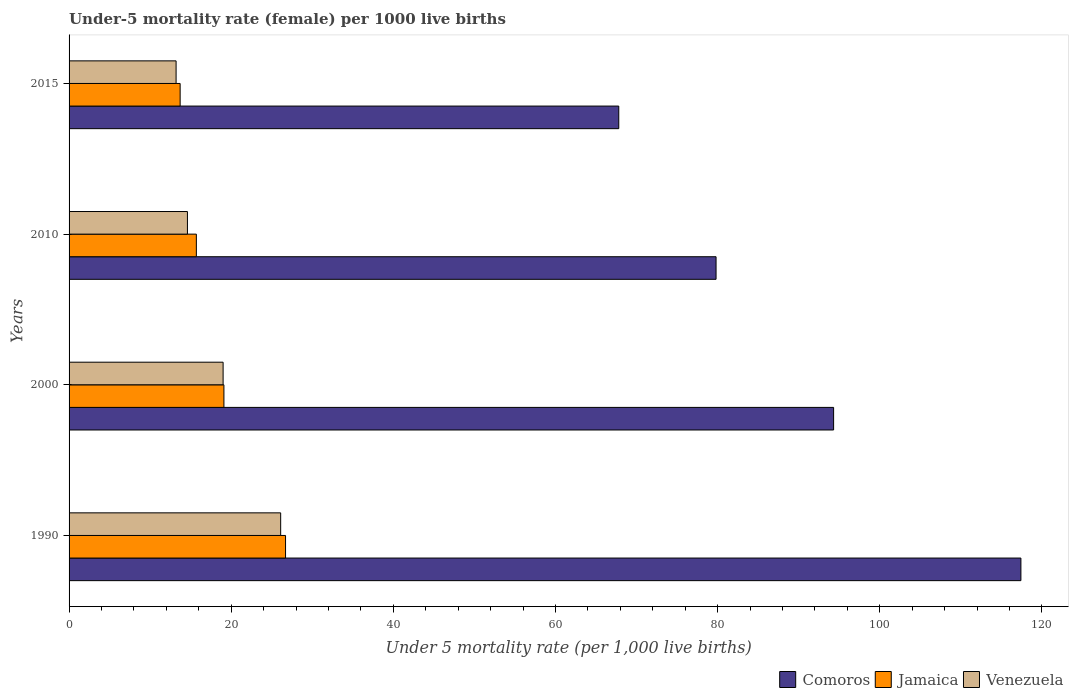How many different coloured bars are there?
Make the answer very short. 3. Are the number of bars on each tick of the Y-axis equal?
Keep it short and to the point. Yes. How many bars are there on the 4th tick from the top?
Provide a short and direct response. 3. What is the label of the 3rd group of bars from the top?
Offer a terse response. 2000. What is the under-five mortality rate in Comoros in 1990?
Keep it short and to the point. 117.4. Across all years, what is the maximum under-five mortality rate in Venezuela?
Your response must be concise. 26.1. Across all years, what is the minimum under-five mortality rate in Jamaica?
Keep it short and to the point. 13.7. In which year was the under-five mortality rate in Comoros minimum?
Your answer should be very brief. 2015. What is the total under-five mortality rate in Venezuela in the graph?
Offer a very short reply. 72.9. What is the difference between the under-five mortality rate in Jamaica in 1990 and that in 2000?
Offer a very short reply. 7.6. In the year 2010, what is the difference between the under-five mortality rate in Jamaica and under-five mortality rate in Venezuela?
Offer a terse response. 1.1. In how many years, is the under-five mortality rate in Comoros greater than 4 ?
Your response must be concise. 4. What is the ratio of the under-five mortality rate in Venezuela in 2010 to that in 2015?
Provide a short and direct response. 1.11. Is the under-five mortality rate in Venezuela in 1990 less than that in 2000?
Provide a succinct answer. No. Is the difference between the under-five mortality rate in Jamaica in 2000 and 2010 greater than the difference between the under-five mortality rate in Venezuela in 2000 and 2010?
Your response must be concise. No. What is the difference between the highest and the second highest under-five mortality rate in Venezuela?
Your answer should be very brief. 7.1. Is the sum of the under-five mortality rate in Jamaica in 1990 and 2010 greater than the maximum under-five mortality rate in Comoros across all years?
Make the answer very short. No. What does the 3rd bar from the top in 1990 represents?
Your response must be concise. Comoros. What does the 2nd bar from the bottom in 2010 represents?
Your response must be concise. Jamaica. How many bars are there?
Ensure brevity in your answer.  12. How many years are there in the graph?
Ensure brevity in your answer.  4. What is the difference between two consecutive major ticks on the X-axis?
Offer a terse response. 20. Does the graph contain any zero values?
Provide a succinct answer. No. Where does the legend appear in the graph?
Ensure brevity in your answer.  Bottom right. What is the title of the graph?
Provide a succinct answer. Under-5 mortality rate (female) per 1000 live births. Does "Niger" appear as one of the legend labels in the graph?
Provide a succinct answer. No. What is the label or title of the X-axis?
Your answer should be very brief. Under 5 mortality rate (per 1,0 live births). What is the label or title of the Y-axis?
Give a very brief answer. Years. What is the Under 5 mortality rate (per 1,000 live births) in Comoros in 1990?
Provide a short and direct response. 117.4. What is the Under 5 mortality rate (per 1,000 live births) of Jamaica in 1990?
Your answer should be compact. 26.7. What is the Under 5 mortality rate (per 1,000 live births) of Venezuela in 1990?
Keep it short and to the point. 26.1. What is the Under 5 mortality rate (per 1,000 live births) of Comoros in 2000?
Make the answer very short. 94.3. What is the Under 5 mortality rate (per 1,000 live births) of Comoros in 2010?
Offer a very short reply. 79.8. What is the Under 5 mortality rate (per 1,000 live births) in Venezuela in 2010?
Keep it short and to the point. 14.6. What is the Under 5 mortality rate (per 1,000 live births) of Comoros in 2015?
Your response must be concise. 67.8. What is the Under 5 mortality rate (per 1,000 live births) of Jamaica in 2015?
Your answer should be very brief. 13.7. What is the Under 5 mortality rate (per 1,000 live births) of Venezuela in 2015?
Ensure brevity in your answer.  13.2. Across all years, what is the maximum Under 5 mortality rate (per 1,000 live births) in Comoros?
Ensure brevity in your answer.  117.4. Across all years, what is the maximum Under 5 mortality rate (per 1,000 live births) of Jamaica?
Your answer should be compact. 26.7. Across all years, what is the maximum Under 5 mortality rate (per 1,000 live births) of Venezuela?
Your response must be concise. 26.1. Across all years, what is the minimum Under 5 mortality rate (per 1,000 live births) in Comoros?
Provide a succinct answer. 67.8. Across all years, what is the minimum Under 5 mortality rate (per 1,000 live births) of Jamaica?
Offer a very short reply. 13.7. Across all years, what is the minimum Under 5 mortality rate (per 1,000 live births) in Venezuela?
Give a very brief answer. 13.2. What is the total Under 5 mortality rate (per 1,000 live births) in Comoros in the graph?
Your answer should be compact. 359.3. What is the total Under 5 mortality rate (per 1,000 live births) of Jamaica in the graph?
Make the answer very short. 75.2. What is the total Under 5 mortality rate (per 1,000 live births) of Venezuela in the graph?
Provide a short and direct response. 72.9. What is the difference between the Under 5 mortality rate (per 1,000 live births) of Comoros in 1990 and that in 2000?
Offer a very short reply. 23.1. What is the difference between the Under 5 mortality rate (per 1,000 live births) of Jamaica in 1990 and that in 2000?
Provide a succinct answer. 7.6. What is the difference between the Under 5 mortality rate (per 1,000 live births) in Venezuela in 1990 and that in 2000?
Provide a short and direct response. 7.1. What is the difference between the Under 5 mortality rate (per 1,000 live births) of Comoros in 1990 and that in 2010?
Your answer should be compact. 37.6. What is the difference between the Under 5 mortality rate (per 1,000 live births) of Venezuela in 1990 and that in 2010?
Your response must be concise. 11.5. What is the difference between the Under 5 mortality rate (per 1,000 live births) of Comoros in 1990 and that in 2015?
Make the answer very short. 49.6. What is the difference between the Under 5 mortality rate (per 1,000 live births) in Jamaica in 1990 and that in 2015?
Your answer should be very brief. 13. What is the difference between the Under 5 mortality rate (per 1,000 live births) of Venezuela in 1990 and that in 2015?
Your answer should be compact. 12.9. What is the difference between the Under 5 mortality rate (per 1,000 live births) of Jamaica in 2000 and that in 2010?
Your answer should be very brief. 3.4. What is the difference between the Under 5 mortality rate (per 1,000 live births) in Venezuela in 2000 and that in 2010?
Offer a very short reply. 4.4. What is the difference between the Under 5 mortality rate (per 1,000 live births) in Jamaica in 2000 and that in 2015?
Keep it short and to the point. 5.4. What is the difference between the Under 5 mortality rate (per 1,000 live births) of Venezuela in 2010 and that in 2015?
Offer a very short reply. 1.4. What is the difference between the Under 5 mortality rate (per 1,000 live births) in Comoros in 1990 and the Under 5 mortality rate (per 1,000 live births) in Jamaica in 2000?
Your response must be concise. 98.3. What is the difference between the Under 5 mortality rate (per 1,000 live births) in Comoros in 1990 and the Under 5 mortality rate (per 1,000 live births) in Venezuela in 2000?
Your answer should be compact. 98.4. What is the difference between the Under 5 mortality rate (per 1,000 live births) of Jamaica in 1990 and the Under 5 mortality rate (per 1,000 live births) of Venezuela in 2000?
Offer a very short reply. 7.7. What is the difference between the Under 5 mortality rate (per 1,000 live births) in Comoros in 1990 and the Under 5 mortality rate (per 1,000 live births) in Jamaica in 2010?
Make the answer very short. 101.7. What is the difference between the Under 5 mortality rate (per 1,000 live births) of Comoros in 1990 and the Under 5 mortality rate (per 1,000 live births) of Venezuela in 2010?
Make the answer very short. 102.8. What is the difference between the Under 5 mortality rate (per 1,000 live births) in Comoros in 1990 and the Under 5 mortality rate (per 1,000 live births) in Jamaica in 2015?
Give a very brief answer. 103.7. What is the difference between the Under 5 mortality rate (per 1,000 live births) of Comoros in 1990 and the Under 5 mortality rate (per 1,000 live births) of Venezuela in 2015?
Give a very brief answer. 104.2. What is the difference between the Under 5 mortality rate (per 1,000 live births) in Comoros in 2000 and the Under 5 mortality rate (per 1,000 live births) in Jamaica in 2010?
Provide a succinct answer. 78.6. What is the difference between the Under 5 mortality rate (per 1,000 live births) of Comoros in 2000 and the Under 5 mortality rate (per 1,000 live births) of Venezuela in 2010?
Provide a succinct answer. 79.7. What is the difference between the Under 5 mortality rate (per 1,000 live births) of Jamaica in 2000 and the Under 5 mortality rate (per 1,000 live births) of Venezuela in 2010?
Provide a succinct answer. 4.5. What is the difference between the Under 5 mortality rate (per 1,000 live births) in Comoros in 2000 and the Under 5 mortality rate (per 1,000 live births) in Jamaica in 2015?
Offer a terse response. 80.6. What is the difference between the Under 5 mortality rate (per 1,000 live births) of Comoros in 2000 and the Under 5 mortality rate (per 1,000 live births) of Venezuela in 2015?
Make the answer very short. 81.1. What is the difference between the Under 5 mortality rate (per 1,000 live births) in Comoros in 2010 and the Under 5 mortality rate (per 1,000 live births) in Jamaica in 2015?
Make the answer very short. 66.1. What is the difference between the Under 5 mortality rate (per 1,000 live births) of Comoros in 2010 and the Under 5 mortality rate (per 1,000 live births) of Venezuela in 2015?
Your answer should be compact. 66.6. What is the difference between the Under 5 mortality rate (per 1,000 live births) of Jamaica in 2010 and the Under 5 mortality rate (per 1,000 live births) of Venezuela in 2015?
Offer a very short reply. 2.5. What is the average Under 5 mortality rate (per 1,000 live births) of Comoros per year?
Your answer should be very brief. 89.83. What is the average Under 5 mortality rate (per 1,000 live births) in Venezuela per year?
Keep it short and to the point. 18.23. In the year 1990, what is the difference between the Under 5 mortality rate (per 1,000 live births) in Comoros and Under 5 mortality rate (per 1,000 live births) in Jamaica?
Your answer should be compact. 90.7. In the year 1990, what is the difference between the Under 5 mortality rate (per 1,000 live births) of Comoros and Under 5 mortality rate (per 1,000 live births) of Venezuela?
Offer a very short reply. 91.3. In the year 1990, what is the difference between the Under 5 mortality rate (per 1,000 live births) in Jamaica and Under 5 mortality rate (per 1,000 live births) in Venezuela?
Your answer should be very brief. 0.6. In the year 2000, what is the difference between the Under 5 mortality rate (per 1,000 live births) of Comoros and Under 5 mortality rate (per 1,000 live births) of Jamaica?
Provide a short and direct response. 75.2. In the year 2000, what is the difference between the Under 5 mortality rate (per 1,000 live births) in Comoros and Under 5 mortality rate (per 1,000 live births) in Venezuela?
Keep it short and to the point. 75.3. In the year 2010, what is the difference between the Under 5 mortality rate (per 1,000 live births) in Comoros and Under 5 mortality rate (per 1,000 live births) in Jamaica?
Keep it short and to the point. 64.1. In the year 2010, what is the difference between the Under 5 mortality rate (per 1,000 live births) in Comoros and Under 5 mortality rate (per 1,000 live births) in Venezuela?
Keep it short and to the point. 65.2. In the year 2015, what is the difference between the Under 5 mortality rate (per 1,000 live births) in Comoros and Under 5 mortality rate (per 1,000 live births) in Jamaica?
Make the answer very short. 54.1. In the year 2015, what is the difference between the Under 5 mortality rate (per 1,000 live births) of Comoros and Under 5 mortality rate (per 1,000 live births) of Venezuela?
Offer a terse response. 54.6. What is the ratio of the Under 5 mortality rate (per 1,000 live births) in Comoros in 1990 to that in 2000?
Your answer should be very brief. 1.25. What is the ratio of the Under 5 mortality rate (per 1,000 live births) in Jamaica in 1990 to that in 2000?
Make the answer very short. 1.4. What is the ratio of the Under 5 mortality rate (per 1,000 live births) in Venezuela in 1990 to that in 2000?
Ensure brevity in your answer.  1.37. What is the ratio of the Under 5 mortality rate (per 1,000 live births) in Comoros in 1990 to that in 2010?
Offer a very short reply. 1.47. What is the ratio of the Under 5 mortality rate (per 1,000 live births) in Jamaica in 1990 to that in 2010?
Offer a very short reply. 1.7. What is the ratio of the Under 5 mortality rate (per 1,000 live births) of Venezuela in 1990 to that in 2010?
Provide a short and direct response. 1.79. What is the ratio of the Under 5 mortality rate (per 1,000 live births) of Comoros in 1990 to that in 2015?
Offer a very short reply. 1.73. What is the ratio of the Under 5 mortality rate (per 1,000 live births) of Jamaica in 1990 to that in 2015?
Offer a very short reply. 1.95. What is the ratio of the Under 5 mortality rate (per 1,000 live births) in Venezuela in 1990 to that in 2015?
Offer a terse response. 1.98. What is the ratio of the Under 5 mortality rate (per 1,000 live births) of Comoros in 2000 to that in 2010?
Your response must be concise. 1.18. What is the ratio of the Under 5 mortality rate (per 1,000 live births) in Jamaica in 2000 to that in 2010?
Offer a terse response. 1.22. What is the ratio of the Under 5 mortality rate (per 1,000 live births) of Venezuela in 2000 to that in 2010?
Keep it short and to the point. 1.3. What is the ratio of the Under 5 mortality rate (per 1,000 live births) in Comoros in 2000 to that in 2015?
Ensure brevity in your answer.  1.39. What is the ratio of the Under 5 mortality rate (per 1,000 live births) in Jamaica in 2000 to that in 2015?
Your response must be concise. 1.39. What is the ratio of the Under 5 mortality rate (per 1,000 live births) in Venezuela in 2000 to that in 2015?
Your response must be concise. 1.44. What is the ratio of the Under 5 mortality rate (per 1,000 live births) in Comoros in 2010 to that in 2015?
Offer a terse response. 1.18. What is the ratio of the Under 5 mortality rate (per 1,000 live births) in Jamaica in 2010 to that in 2015?
Keep it short and to the point. 1.15. What is the ratio of the Under 5 mortality rate (per 1,000 live births) in Venezuela in 2010 to that in 2015?
Keep it short and to the point. 1.11. What is the difference between the highest and the second highest Under 5 mortality rate (per 1,000 live births) in Comoros?
Keep it short and to the point. 23.1. What is the difference between the highest and the lowest Under 5 mortality rate (per 1,000 live births) in Comoros?
Give a very brief answer. 49.6. What is the difference between the highest and the lowest Under 5 mortality rate (per 1,000 live births) in Jamaica?
Provide a short and direct response. 13. 